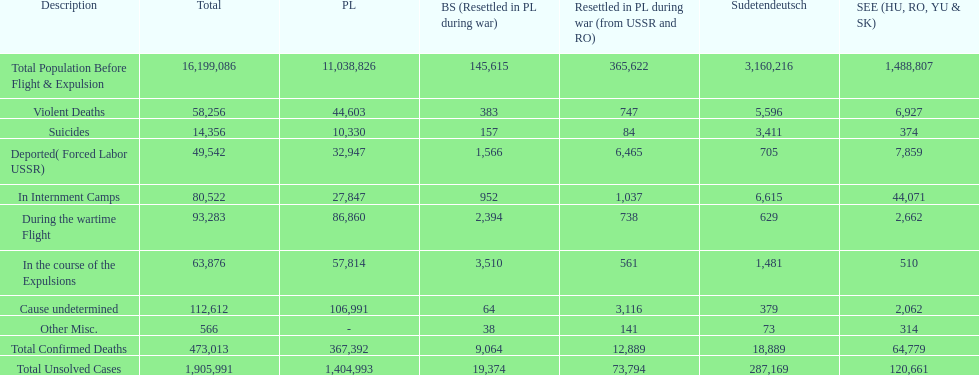Was there a larger total population before expulsion in poland or sudetendeutsch? Poland. 